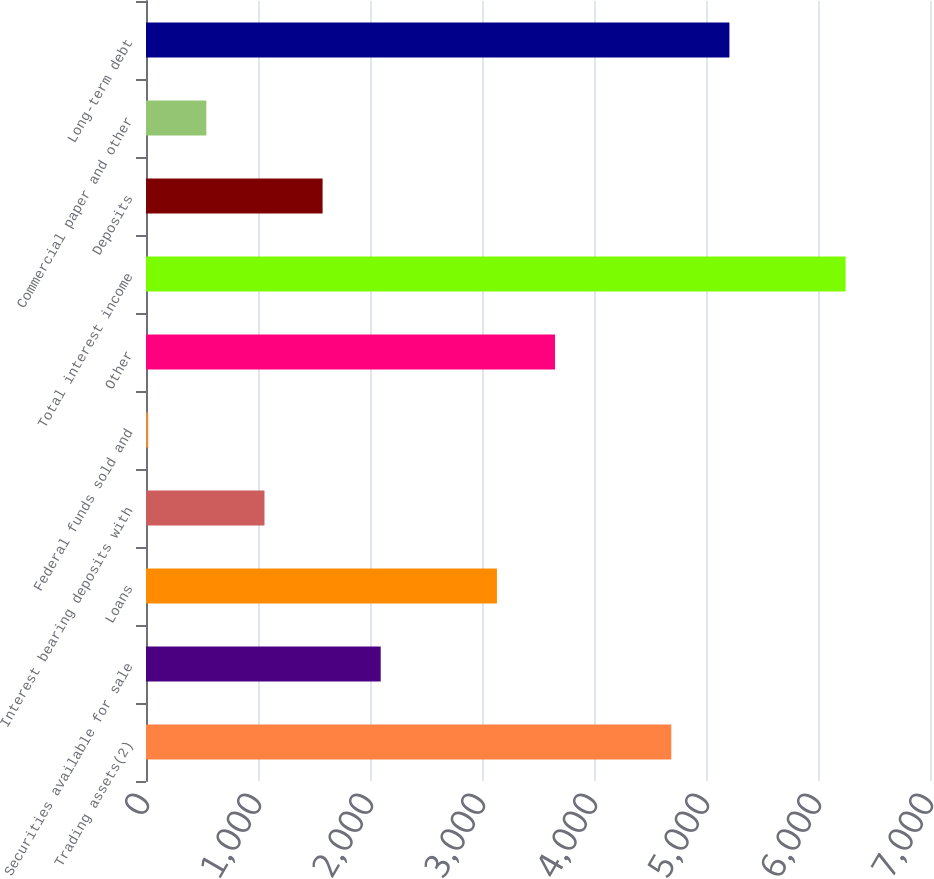Convert chart to OTSL. <chart><loc_0><loc_0><loc_500><loc_500><bar_chart><fcel>Trading assets(2)<fcel>Securities available for sale<fcel>Loans<fcel>Interest bearing deposits with<fcel>Federal funds sold and<fcel>Other<fcel>Total interest income<fcel>Deposits<fcel>Commercial paper and other<fcel>Long-term debt<nl><fcel>4690.1<fcel>2095.6<fcel>3133.4<fcel>1057.8<fcel>20<fcel>3652.3<fcel>6246.8<fcel>1576.7<fcel>538.9<fcel>5209<nl></chart> 